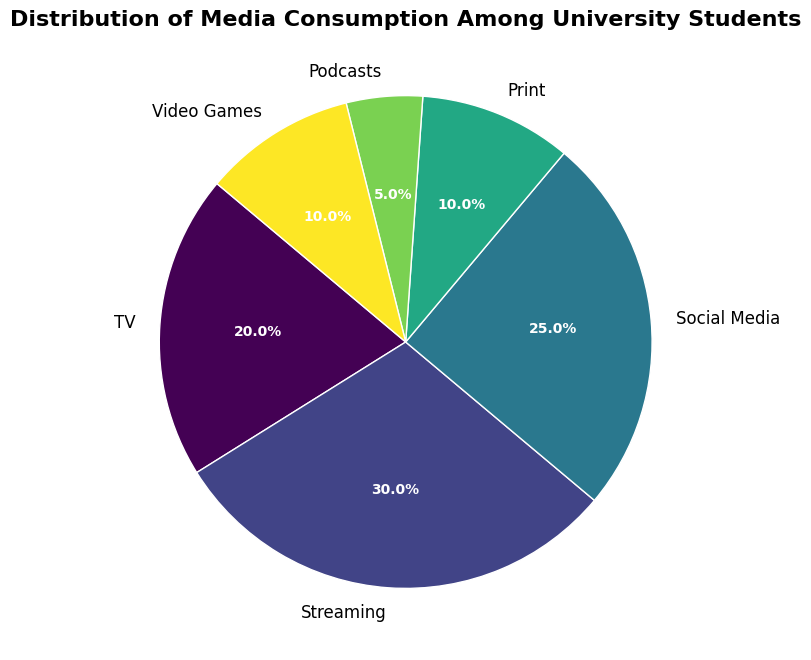What is the largest category in the pie chart? The largest segment in the pie chart can be identified by looking at the percentages labeled next to each category. The largest category will have the highest percentage.
Answer: Streaming Which two categories combined make up 50% of the total media consumption? To find two categories that combined make up 50% of the total, look for two segments whose percentages add up to 50%. Here, Streaming (30%) and Social Media (25%) together account for more than 50%, while the only pairs making 50% are Streaming (30%) and TV (20%).
Answer: Streaming and TV What is the difference in percentage between Social Media and Podcasts? To find the difference in percentage between Social Media and Podcasts, subtract the percentage of Podcasts from the percentage of Social Media. That is, 25% - 5% = 20%.
Answer: 20% Among Social Media, Print, and Video Games, which category has the lowest media consumption? Compare the labeled percentages of Social Media (25%), Print (10%), and Video Games (10%). The category with the smallest percentage has the lowest consumption. Print (10%) and Video Games (10%) are the smallest but they have the same value.
Answer: Print and Video Games What is the total percentage for the categories other than Streaming? Subtract the percentage of Streaming from 100%. That is, 100% - 30% = 70%. Alternatively, this can be summed as TV (20%) + Social Media (25%) + Print (10%) + Podcasts (5%) + Video Games (10%) = 70%.
Answer: 70% Which category uses the yellow color in the pie chart, and what is its percentage? By examining the colors assigned to each category in the pie chart, identify which is yellow and note the corresponding percentage label. Streaming (30%) uses the yellow color.
Answer: Streaming, 30% How many categories have a media consumption percentage of 10% or more? Count the number of segments with a labeled percentage of 10% or higher. TV (20%), Streaming (30%), Social Media (25%), Print (10%), and Video Games (10%) meet this criterion, making it 5 categories.
Answer: 5 What is the average percentage of TV and Video Games combined? To find the average, first sum the percentages for TV and Video Games, then divide by 2. (20% + 10%) / 2 = 15%.
Answer: 15% 